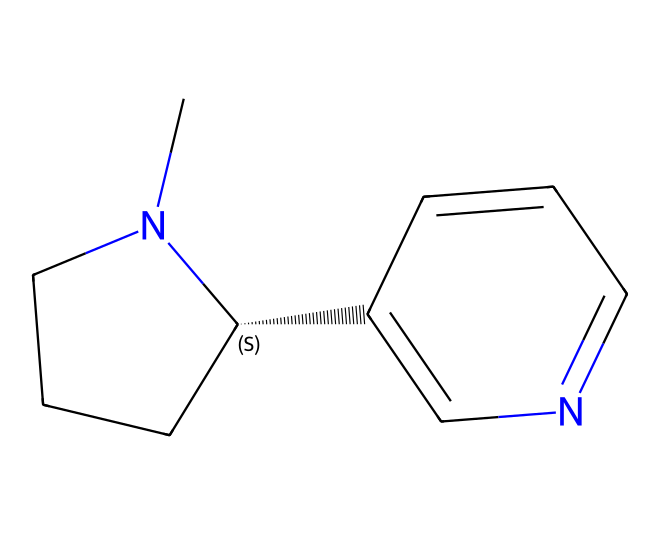What is the primary element in nicotine? The structure contains a significant amount of carbon atoms and nitrogen atoms, with the arrangement indicating that carbon is the primary element forming the backbone of the structure.
Answer: carbon How many rings are present in the nicotine structure? Analyzing the structure reveals two connected rings; the cyclic parts of the molecule contribute to its overall stability and reactivity.
Answer: 2 What functional groups are present in nicotine? The presence of nitrogen atoms in a heterocyclic ring suggests the presence of amine and aromatic functional groups, which define its chemical behavior.
Answer: amine, aromatic What is the molecular formula of nicotine? By counting the atoms represented in the structure, including carbon, hydrogen, and nitrogen, we find that nicotine has the formula C10H14N2.
Answer: C10H14N2 What type of chemical is nicotine classified as? Given its structure contains nitrogen in a cyclic format and its occurrence in tobacco, nicotine is classified as an alkaloid.
Answer: alkaloid Is nicotine a toxic substance? Analyzing its chemical properties and effects on the human nervous system indicates that nicotine is indeed considered a toxic substance, especially with its potential for addiction.
Answer: yes 